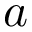Convert formula to latex. <formula><loc_0><loc_0><loc_500><loc_500>a</formula> 